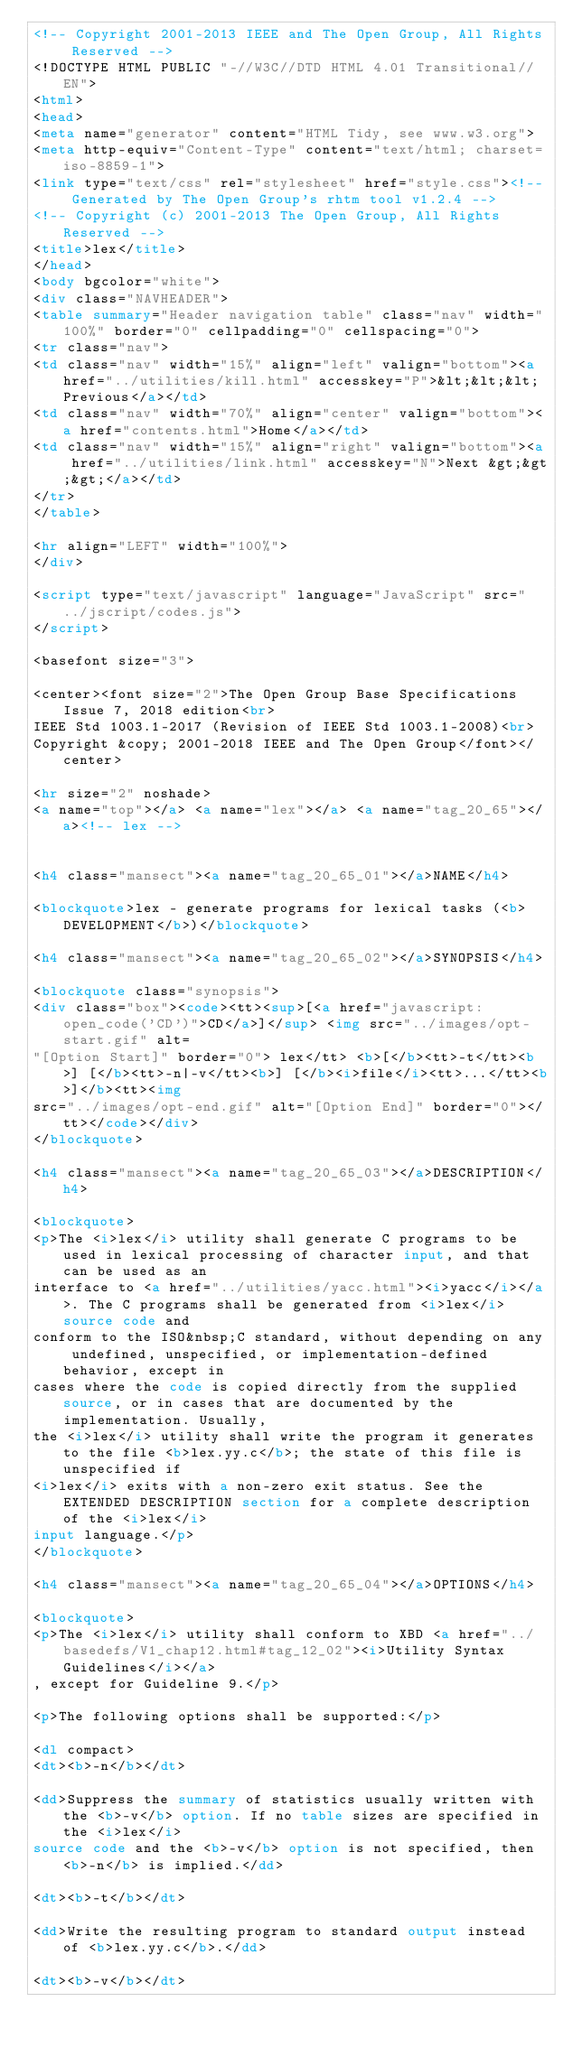<code> <loc_0><loc_0><loc_500><loc_500><_HTML_><!-- Copyright 2001-2013 IEEE and The Open Group, All Rights Reserved -->
<!DOCTYPE HTML PUBLIC "-//W3C//DTD HTML 4.01 Transitional//EN">
<html>
<head>
<meta name="generator" content="HTML Tidy, see www.w3.org">
<meta http-equiv="Content-Type" content="text/html; charset=iso-8859-1">
<link type="text/css" rel="stylesheet" href="style.css"><!-- Generated by The Open Group's rhtm tool v1.2.4 -->
<!-- Copyright (c) 2001-2013 The Open Group, All Rights Reserved -->
<title>lex</title>
</head>
<body bgcolor="white">
<div class="NAVHEADER">
<table summary="Header navigation table" class="nav" width="100%" border="0" cellpadding="0" cellspacing="0">
<tr class="nav">
<td class="nav" width="15%" align="left" valign="bottom"><a href="../utilities/kill.html" accesskey="P">&lt;&lt;&lt; Previous</a></td>
<td class="nav" width="70%" align="center" valign="bottom"><a href="contents.html">Home</a></td>
<td class="nav" width="15%" align="right" valign="bottom"><a href="../utilities/link.html" accesskey="N">Next &gt;&gt;&gt;</a></td>
</tr>
</table>

<hr align="LEFT" width="100%">
</div>

<script type="text/javascript" language="JavaScript" src="../jscript/codes.js">
</script>

<basefont size="3"> 

<center><font size="2">The Open Group Base Specifications Issue 7, 2018 edition<br>
IEEE Std 1003.1-2017 (Revision of IEEE Std 1003.1-2008)<br>
Copyright &copy; 2001-2018 IEEE and The Open Group</font></center>

<hr size="2" noshade>
<a name="top"></a> <a name="lex"></a> <a name="tag_20_65"></a><!-- lex -->
 

<h4 class="mansect"><a name="tag_20_65_01"></a>NAME</h4>

<blockquote>lex - generate programs for lexical tasks (<b>DEVELOPMENT</b>)</blockquote>

<h4 class="mansect"><a name="tag_20_65_02"></a>SYNOPSIS</h4>

<blockquote class="synopsis">
<div class="box"><code><tt><sup>[<a href="javascript:open_code('CD')">CD</a>]</sup> <img src="../images/opt-start.gif" alt=
"[Option Start]" border="0"> lex</tt> <b>[</b><tt>-t</tt><b>] [</b><tt>-n|-v</tt><b>] [</b><i>file</i><tt>...</tt><b>]</b><tt><img
src="../images/opt-end.gif" alt="[Option End]" border="0"></tt></code></div>
</blockquote>

<h4 class="mansect"><a name="tag_20_65_03"></a>DESCRIPTION</h4>

<blockquote>
<p>The <i>lex</i> utility shall generate C programs to be used in lexical processing of character input, and that can be used as an
interface to <a href="../utilities/yacc.html"><i>yacc</i></a>. The C programs shall be generated from <i>lex</i> source code and
conform to the ISO&nbsp;C standard, without depending on any undefined, unspecified, or implementation-defined behavior, except in
cases where the code is copied directly from the supplied source, or in cases that are documented by the implementation. Usually,
the <i>lex</i> utility shall write the program it generates to the file <b>lex.yy.c</b>; the state of this file is unspecified if
<i>lex</i> exits with a non-zero exit status. See the EXTENDED DESCRIPTION section for a complete description of the <i>lex</i>
input language.</p>
</blockquote>

<h4 class="mansect"><a name="tag_20_65_04"></a>OPTIONS</h4>

<blockquote>
<p>The <i>lex</i> utility shall conform to XBD <a href="../basedefs/V1_chap12.html#tag_12_02"><i>Utility Syntax Guidelines</i></a>
, except for Guideline 9.</p>

<p>The following options shall be supported:</p>

<dl compact>
<dt><b>-n</b></dt>

<dd>Suppress the summary of statistics usually written with the <b>-v</b> option. If no table sizes are specified in the <i>lex</i>
source code and the <b>-v</b> option is not specified, then <b>-n</b> is implied.</dd>

<dt><b>-t</b></dt>

<dd>Write the resulting program to standard output instead of <b>lex.yy.c</b>.</dd>

<dt><b>-v</b></dt>
</code> 